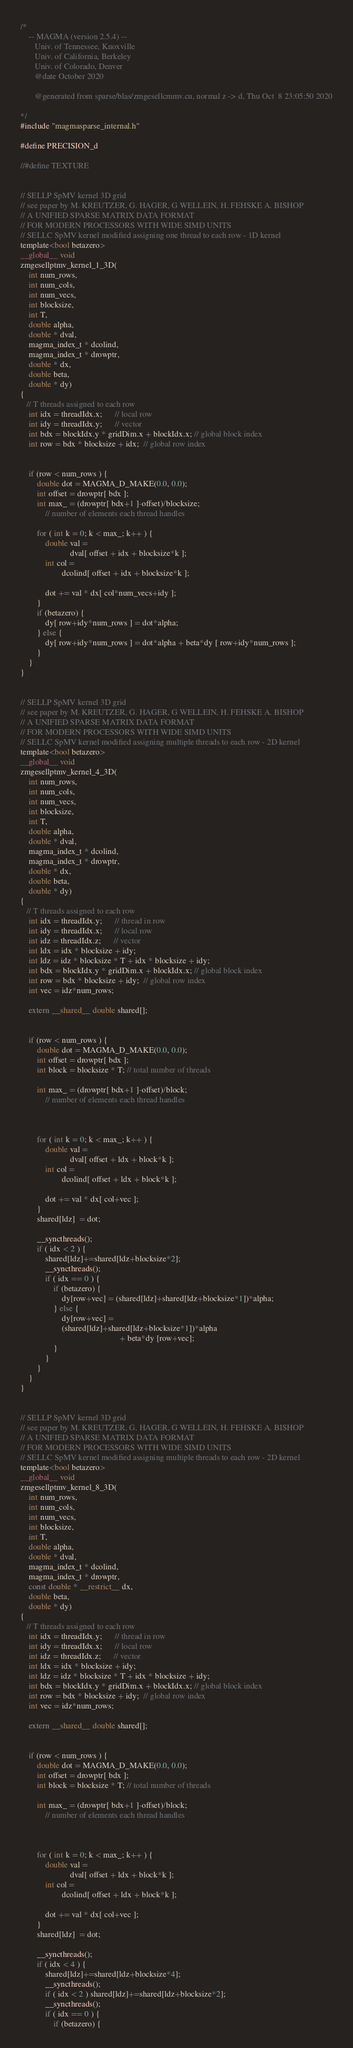Convert code to text. <code><loc_0><loc_0><loc_500><loc_500><_Cuda_>/*
    -- MAGMA (version 2.5.4) --
       Univ. of Tennessee, Knoxville
       Univ. of California, Berkeley
       Univ. of Colorado, Denver
       @date October 2020

       @generated from sparse/blas/zmgesellcmmv.cu, normal z -> d, Thu Oct  8 23:05:50 2020

*/
#include "magmasparse_internal.h"

#define PRECISION_d

//#define TEXTURE


// SELLP SpMV kernel 3D grid
// see paper by M. KREUTZER, G. HAGER, G WELLEIN, H. FEHSKE A. BISHOP
// A UNIFIED SPARSE MATRIX DATA FORMAT 
// FOR MODERN PROCESSORS WITH WIDE SIMD UNITS
// SELLC SpMV kernel modified assigning one thread to each row - 1D kernel
template<bool betazero>
__global__ void 
zmgesellptmv_kernel_1_3D( 
    int num_rows, 
    int num_cols,
    int num_vecs,
    int blocksize,
    int T,
    double alpha, 
    double * dval, 
    magma_index_t * dcolind,
    magma_index_t * drowptr,
    double * dx,
    double beta, 
    double * dy)
{
   // T threads assigned to each row
    int idx = threadIdx.x;      // local row
    int idy = threadIdx.y;      // vector
    int bdx = blockIdx.y * gridDim.x + blockIdx.x; // global block index
    int row = bdx * blocksize + idx;  // global row index


    if (row < num_rows ) {
        double dot = MAGMA_D_MAKE(0.0, 0.0);
        int offset = drowptr[ bdx ];
        int max_ = (drowptr[ bdx+1 ]-offset)/blocksize;  
            // number of elements each thread handles

        for ( int k = 0; k < max_; k++ ) {
            double val = 
                        dval[ offset + idx + blocksize*k ];
            int col = 
                    dcolind[ offset + idx + blocksize*k ];

            dot += val * dx[ col*num_vecs+idy ];
        }
        if (betazero) {
            dy[ row+idy*num_rows ] = dot*alpha;
        } else {
            dy[ row+idy*num_rows ] = dot*alpha + beta*dy [ row+idy*num_rows ];
        }
    }
}


// SELLP SpMV kernel 3D grid
// see paper by M. KREUTZER, G. HAGER, G WELLEIN, H. FEHSKE A. BISHOP
// A UNIFIED SPARSE MATRIX DATA FORMAT 
// FOR MODERN PROCESSORS WITH WIDE SIMD UNITS
// SELLC SpMV kernel modified assigning multiple threads to each row - 2D kernel
template<bool betazero>
__global__ void 
zmgesellptmv_kernel_4_3D( 
    int num_rows, 
    int num_cols,
    int num_vecs,
    int blocksize,
    int T,
    double alpha, 
    double * dval, 
    magma_index_t * dcolind,
    magma_index_t * drowptr,
    double * dx,
    double beta, 
    double * dy)
{
   // T threads assigned to each row
    int idx = threadIdx.y;      // thread in row
    int idy = threadIdx.x;      // local row
    int idz = threadIdx.z;      // vector
    int ldx = idx * blocksize + idy;
    int ldz = idz * blocksize * T + idx * blocksize + idy;
    int bdx = blockIdx.y * gridDim.x + blockIdx.x; // global block index
    int row = bdx * blocksize + idy;  // global row index
    int vec = idz*num_rows;

    extern __shared__ double shared[];


    if (row < num_rows ) {
        double dot = MAGMA_D_MAKE(0.0, 0.0);
        int offset = drowptr[ bdx ];
        int block = blocksize * T; // total number of threads

        int max_ = (drowptr[ bdx+1 ]-offset)/block;  
            // number of elements each thread handles



        for ( int k = 0; k < max_; k++ ) {
            double val = 
                        dval[ offset + ldx + block*k ];
            int col = 
                    dcolind[ offset + ldx + block*k ];

            dot += val * dx[ col+vec ];
        }
        shared[ldz]  = dot;

        __syncthreads();
        if ( idx < 2 ) {
            shared[ldz]+=shared[ldz+blocksize*2];               
            __syncthreads();
            if ( idx == 0 ) {
                if (betazero) {
                    dy[row+vec] = (shared[ldz]+shared[ldz+blocksize*1])*alpha; 
                } else {
                    dy[row+vec] = 
                    (shared[ldz]+shared[ldz+blocksize*1])*alpha 
                                                + beta*dy [row+vec];
                }
            }
        }
    }
}


// SELLP SpMV kernel 3D grid
// see paper by M. KREUTZER, G. HAGER, G WELLEIN, H. FEHSKE A. BISHOP
// A UNIFIED SPARSE MATRIX DATA FORMAT 
// FOR MODERN PROCESSORS WITH WIDE SIMD UNITS
// SELLC SpMV kernel modified assigning multiple threads to each row - 2D kernel
template<bool betazero>
__global__ void 
zmgesellptmv_kernel_8_3D( 
    int num_rows, 
    int num_cols,
    int num_vecs,
    int blocksize,
    int T,
    double alpha, 
    double * dval, 
    magma_index_t * dcolind,
    magma_index_t * drowptr,
    const double * __restrict__ dx,
    double beta, 
    double * dy)
{
   // T threads assigned to each row
    int idx = threadIdx.y;      // thread in row
    int idy = threadIdx.x;      // local row
    int idz = threadIdx.z;      // vector
    int ldx = idx * blocksize + idy;
    int ldz = idz * blocksize * T + idx * blocksize + idy;
    int bdx = blockIdx.y * gridDim.x + blockIdx.x; // global block index
    int row = bdx * blocksize + idy;  // global row index
    int vec = idz*num_rows;

    extern __shared__ double shared[];


    if (row < num_rows ) {
        double dot = MAGMA_D_MAKE(0.0, 0.0);
        int offset = drowptr[ bdx ];
        int block = blocksize * T; // total number of threads

        int max_ = (drowptr[ bdx+1 ]-offset)/block;  
            // number of elements each thread handles



        for ( int k = 0; k < max_; k++ ) {
            double val = 
                        dval[ offset + ldx + block*k ];
            int col = 
                    dcolind[ offset + ldx + block*k ];

            dot += val * dx[ col+vec ];
        }
        shared[ldz]  = dot;

        __syncthreads();
        if ( idx < 4 ) {
            shared[ldz]+=shared[ldz+blocksize*4];               
            __syncthreads();
            if ( idx < 2 ) shared[ldz]+=shared[ldz+blocksize*2];   
            __syncthreads();
            if ( idx == 0 ) {
                if (betazero) {</code> 